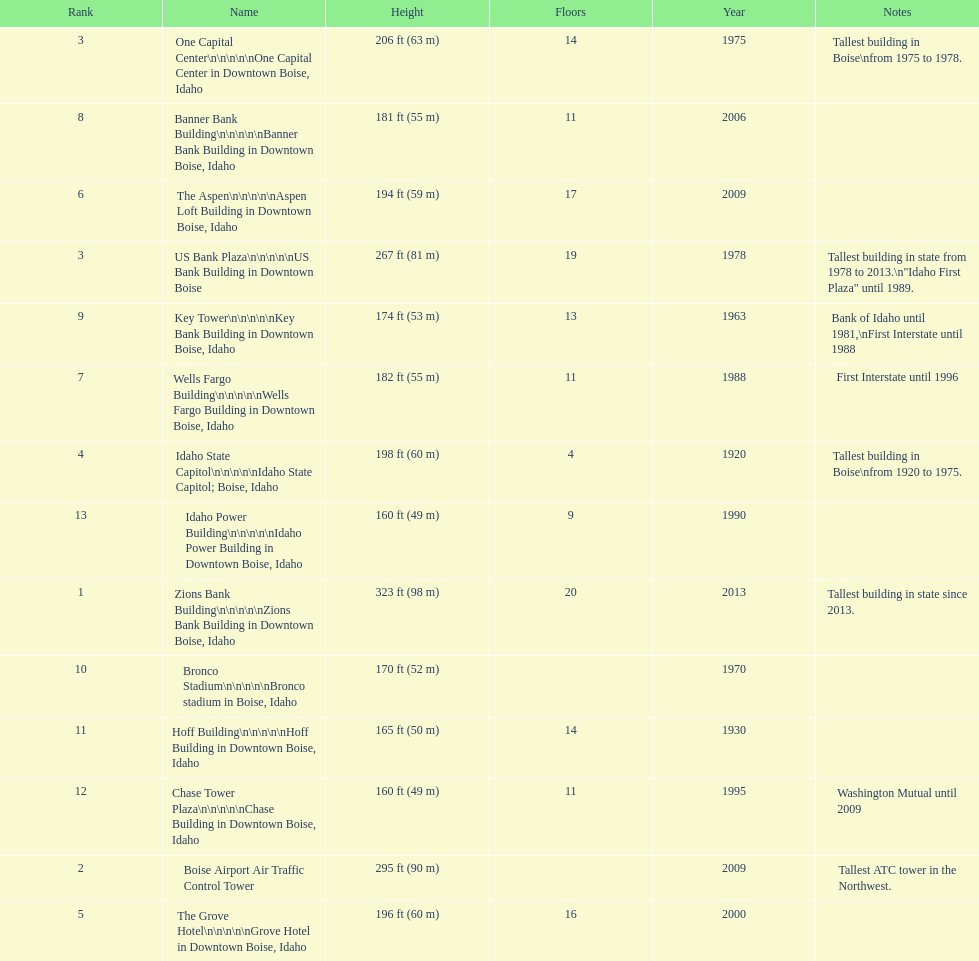How many buildings have at least ten floors? 10. 